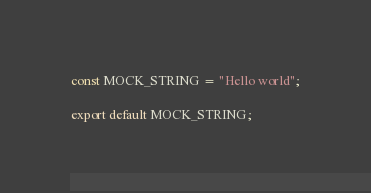Convert code to text. <code><loc_0><loc_0><loc_500><loc_500><_JavaScript_>const MOCK_STRING = "Hello world";

export default MOCK_STRING;
</code> 